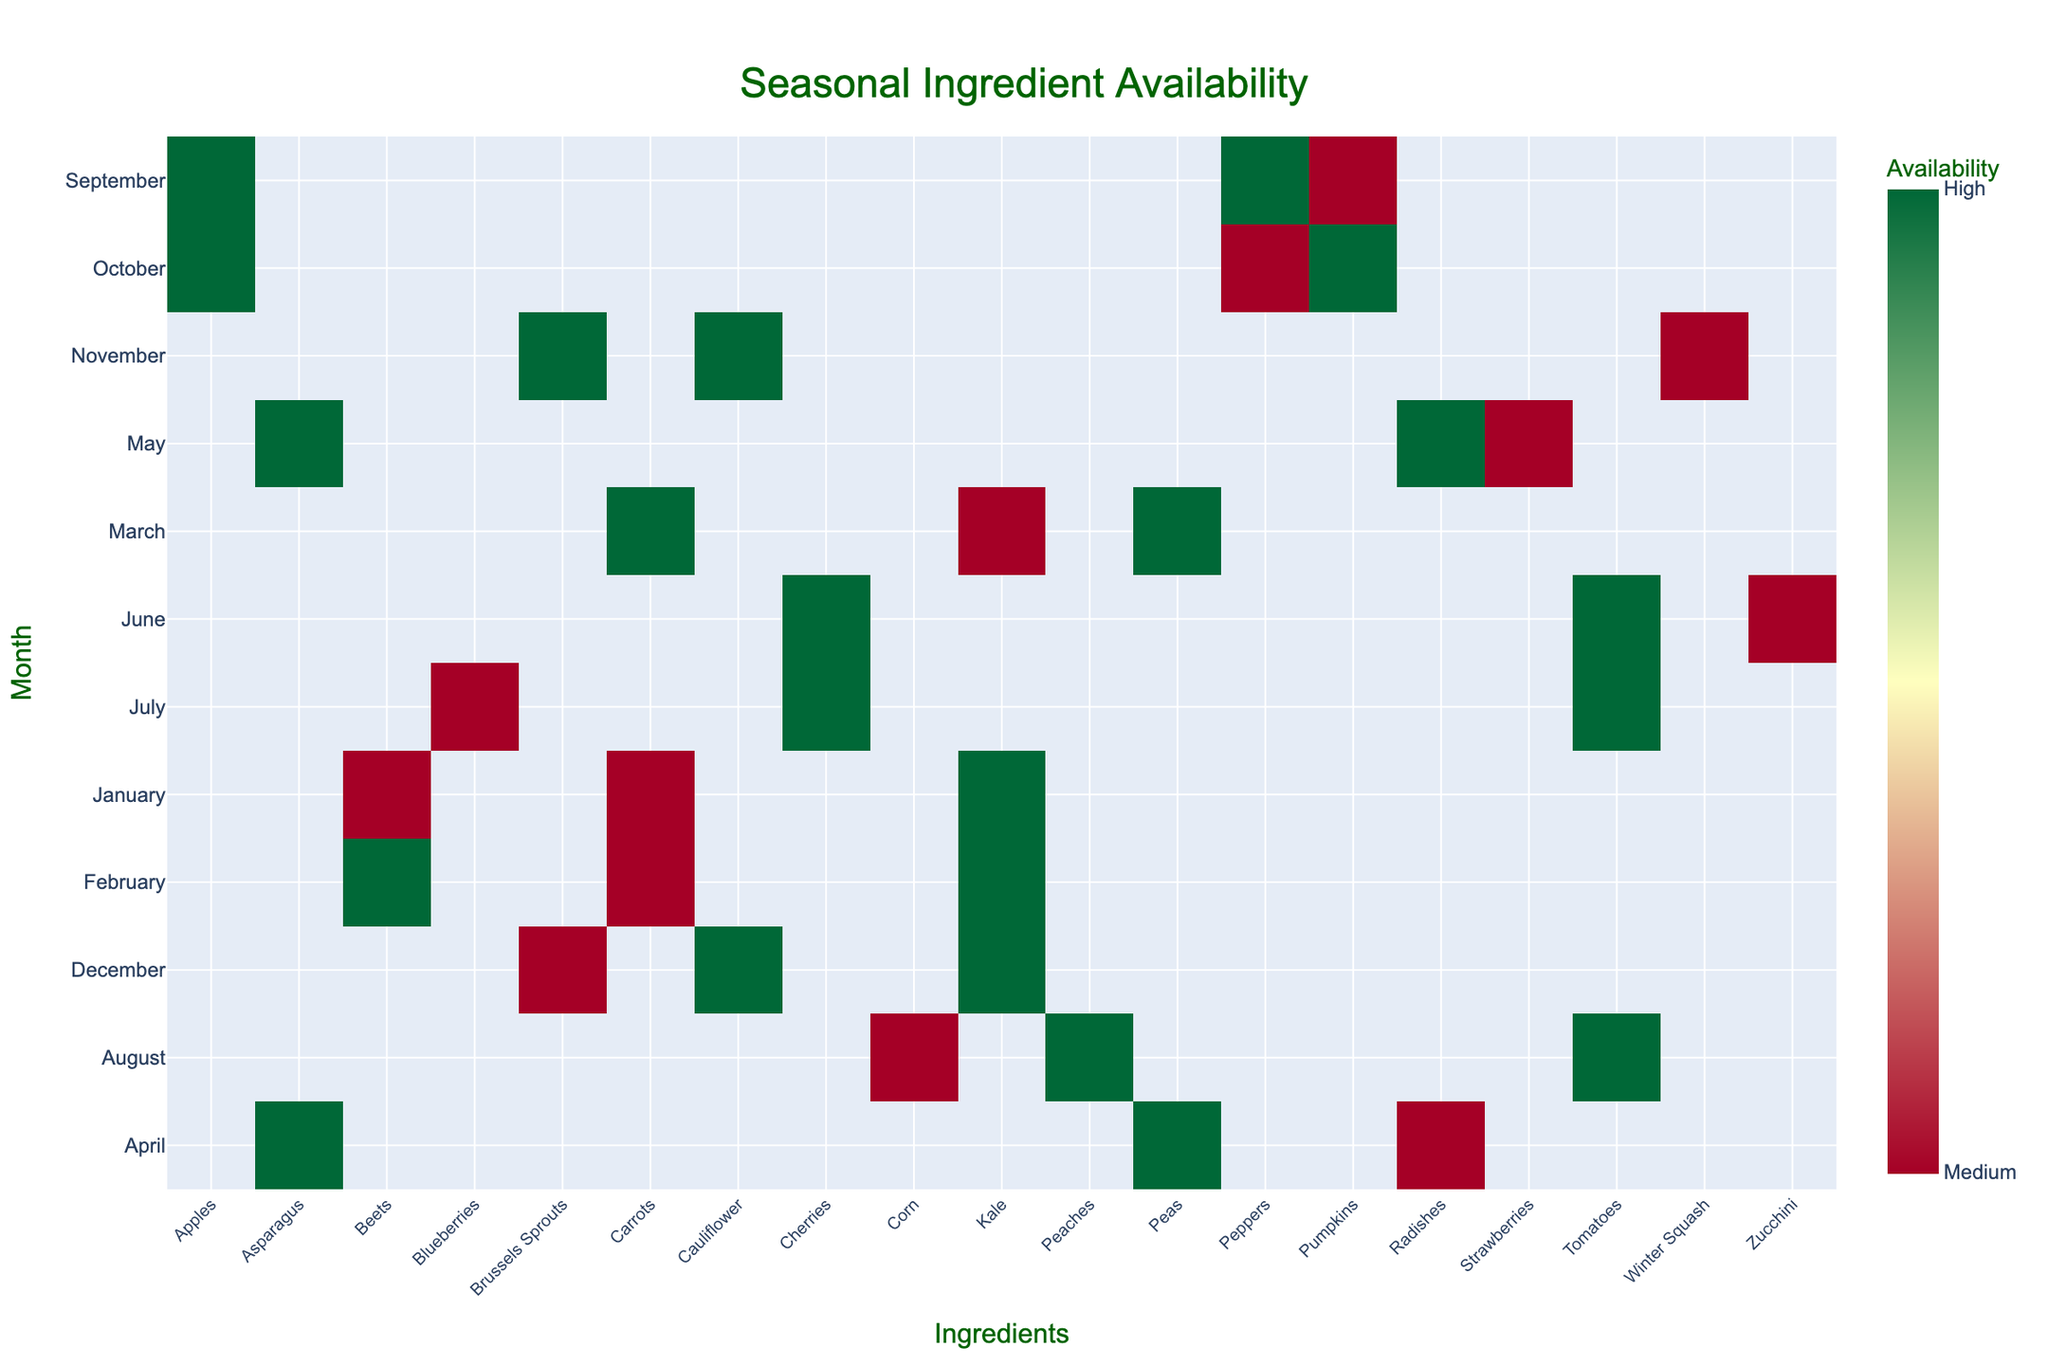What is the title of the figure? The title of the figure is often located at the top center, providing a summary of the data.
Answer: Seasonal Ingredient Availability Which ingredient has high availability in March? To answer this, locate March on the y-axis and look for the ingredients with the color indicating high availability (green).
Answer: Carrots and Peas During which months is Kale highly available? Find Kale along the x-axis and check the months where the color corresponds to high availability (green).
Answer: January, February, December What can you say about the availability of Brussels Sprouts in November and December? Look for Brussels Sprouts on the x-axis and then observe the colors for November and December. Dark green indicates high in November, while light green indicates medium in December.
Answer: November High, December Medium Which month has the highest number of ingredients with medium availability? Examine each month on the y-axis and count the number of medium availability colors (yellow).
Answer: January (two ingredients: Beets, Carrots) Compare the availability of Tomatoes across different months. Locate Tomatoes on the x-axis and observe the colors across the months to see the variations. It’s high in all its available months (June, July, August).
Answer: Always High Are there any ingredients available in only one specific month? Look for ingredients along the x-axis with just one corresponding bar.
Answer: Cherries (June and July), Blueberries (July), Peaches (August) How does the availability of Peppers change from September to October? Examine the colors for Peppers in September and October on the y-axis. September shows high (green) and October shows medium (yellow).
Answer: High in September, Medium in October In which month is Winter Squash available, and what is its availability? Locate Winter Squash on the x-axis and find the corresponding month, then observe the color.
Answer: November Medium Which ingredient shows a highest availability during the summer months (June, July, August)? Check the summer months and find ingredients that consistently show dark green colors.
Answer: Tomatoes 